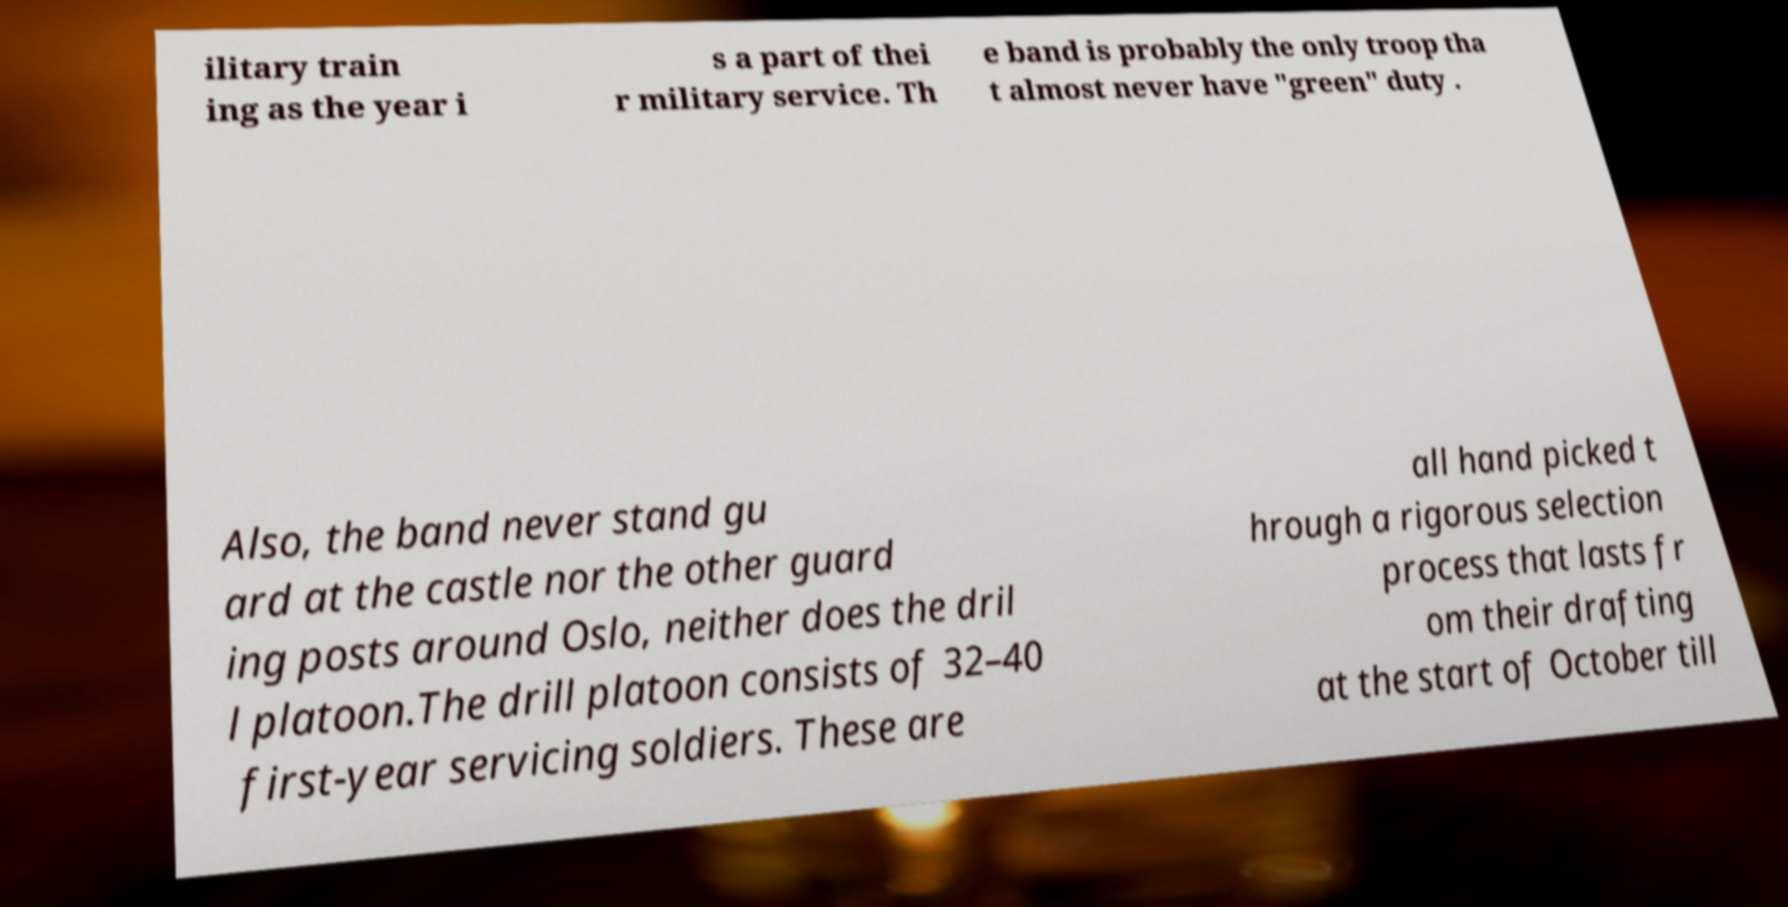Please identify and transcribe the text found in this image. ilitary train ing as the year i s a part of thei r military service. Th e band is probably the only troop tha t almost never have "green" duty . Also, the band never stand gu ard at the castle nor the other guard ing posts around Oslo, neither does the dril l platoon.The drill platoon consists of 32–40 first-year servicing soldiers. These are all hand picked t hrough a rigorous selection process that lasts fr om their drafting at the start of October till 